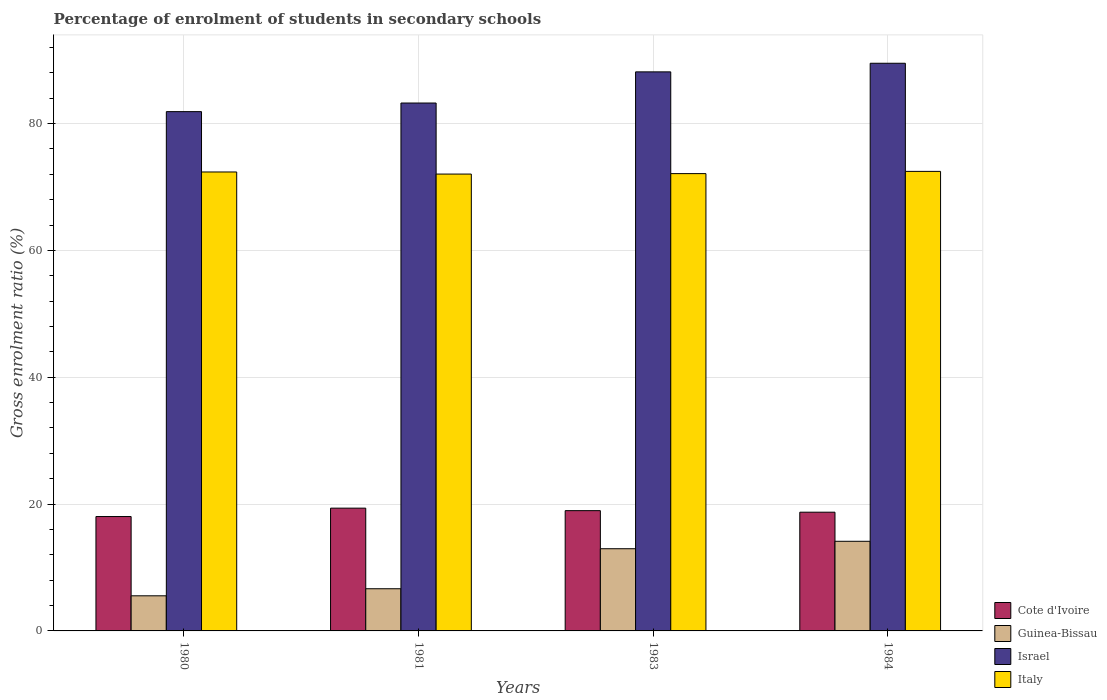How many different coloured bars are there?
Keep it short and to the point. 4. How many groups of bars are there?
Keep it short and to the point. 4. How many bars are there on the 3rd tick from the right?
Give a very brief answer. 4. In how many cases, is the number of bars for a given year not equal to the number of legend labels?
Offer a very short reply. 0. What is the percentage of students enrolled in secondary schools in Cote d'Ivoire in 1983?
Keep it short and to the point. 18.97. Across all years, what is the maximum percentage of students enrolled in secondary schools in Israel?
Offer a very short reply. 89.51. Across all years, what is the minimum percentage of students enrolled in secondary schools in Israel?
Offer a terse response. 81.89. In which year was the percentage of students enrolled in secondary schools in Guinea-Bissau minimum?
Provide a succinct answer. 1980. What is the total percentage of students enrolled in secondary schools in Israel in the graph?
Make the answer very short. 342.8. What is the difference between the percentage of students enrolled in secondary schools in Italy in 1983 and that in 1984?
Your answer should be compact. -0.35. What is the difference between the percentage of students enrolled in secondary schools in Israel in 1980 and the percentage of students enrolled in secondary schools in Italy in 1984?
Give a very brief answer. 9.42. What is the average percentage of students enrolled in secondary schools in Cote d'Ivoire per year?
Offer a terse response. 18.77. In the year 1980, what is the difference between the percentage of students enrolled in secondary schools in Guinea-Bissau and percentage of students enrolled in secondary schools in Israel?
Make the answer very short. -76.35. In how many years, is the percentage of students enrolled in secondary schools in Italy greater than 56 %?
Your response must be concise. 4. What is the ratio of the percentage of students enrolled in secondary schools in Italy in 1980 to that in 1981?
Make the answer very short. 1. Is the percentage of students enrolled in secondary schools in Italy in 1981 less than that in 1983?
Keep it short and to the point. Yes. What is the difference between the highest and the second highest percentage of students enrolled in secondary schools in Cote d'Ivoire?
Make the answer very short. 0.39. What is the difference between the highest and the lowest percentage of students enrolled in secondary schools in Italy?
Your answer should be very brief. 0.43. In how many years, is the percentage of students enrolled in secondary schools in Cote d'Ivoire greater than the average percentage of students enrolled in secondary schools in Cote d'Ivoire taken over all years?
Ensure brevity in your answer.  2. Is the sum of the percentage of students enrolled in secondary schools in Italy in 1980 and 1981 greater than the maximum percentage of students enrolled in secondary schools in Cote d'Ivoire across all years?
Ensure brevity in your answer.  Yes. What does the 2nd bar from the right in 1983 represents?
Your answer should be very brief. Israel. How many bars are there?
Keep it short and to the point. 16. How many years are there in the graph?
Provide a short and direct response. 4. How many legend labels are there?
Keep it short and to the point. 4. How are the legend labels stacked?
Make the answer very short. Vertical. What is the title of the graph?
Your response must be concise. Percentage of enrolment of students in secondary schools. Does "Trinidad and Tobago" appear as one of the legend labels in the graph?
Make the answer very short. No. What is the label or title of the Y-axis?
Give a very brief answer. Gross enrolment ratio (%). What is the Gross enrolment ratio (%) in Cote d'Ivoire in 1980?
Provide a short and direct response. 18.04. What is the Gross enrolment ratio (%) of Guinea-Bissau in 1980?
Your answer should be compact. 5.54. What is the Gross enrolment ratio (%) of Israel in 1980?
Offer a terse response. 81.89. What is the Gross enrolment ratio (%) of Italy in 1980?
Provide a succinct answer. 72.37. What is the Gross enrolment ratio (%) of Cote d'Ivoire in 1981?
Make the answer very short. 19.36. What is the Gross enrolment ratio (%) in Guinea-Bissau in 1981?
Provide a succinct answer. 6.65. What is the Gross enrolment ratio (%) in Israel in 1981?
Your response must be concise. 83.25. What is the Gross enrolment ratio (%) in Italy in 1981?
Offer a terse response. 72.04. What is the Gross enrolment ratio (%) of Cote d'Ivoire in 1983?
Provide a short and direct response. 18.97. What is the Gross enrolment ratio (%) of Guinea-Bissau in 1983?
Provide a succinct answer. 12.96. What is the Gross enrolment ratio (%) of Israel in 1983?
Make the answer very short. 88.16. What is the Gross enrolment ratio (%) in Italy in 1983?
Offer a very short reply. 72.11. What is the Gross enrolment ratio (%) in Cote d'Ivoire in 1984?
Your response must be concise. 18.72. What is the Gross enrolment ratio (%) in Guinea-Bissau in 1984?
Ensure brevity in your answer.  14.13. What is the Gross enrolment ratio (%) in Israel in 1984?
Keep it short and to the point. 89.51. What is the Gross enrolment ratio (%) of Italy in 1984?
Keep it short and to the point. 72.47. Across all years, what is the maximum Gross enrolment ratio (%) in Cote d'Ivoire?
Give a very brief answer. 19.36. Across all years, what is the maximum Gross enrolment ratio (%) in Guinea-Bissau?
Your answer should be compact. 14.13. Across all years, what is the maximum Gross enrolment ratio (%) in Israel?
Provide a succinct answer. 89.51. Across all years, what is the maximum Gross enrolment ratio (%) in Italy?
Give a very brief answer. 72.47. Across all years, what is the minimum Gross enrolment ratio (%) of Cote d'Ivoire?
Give a very brief answer. 18.04. Across all years, what is the minimum Gross enrolment ratio (%) of Guinea-Bissau?
Offer a terse response. 5.54. Across all years, what is the minimum Gross enrolment ratio (%) in Israel?
Give a very brief answer. 81.89. Across all years, what is the minimum Gross enrolment ratio (%) of Italy?
Provide a short and direct response. 72.04. What is the total Gross enrolment ratio (%) in Cote d'Ivoire in the graph?
Give a very brief answer. 75.08. What is the total Gross enrolment ratio (%) in Guinea-Bissau in the graph?
Ensure brevity in your answer.  39.28. What is the total Gross enrolment ratio (%) in Israel in the graph?
Give a very brief answer. 342.8. What is the total Gross enrolment ratio (%) in Italy in the graph?
Offer a very short reply. 288.99. What is the difference between the Gross enrolment ratio (%) of Cote d'Ivoire in 1980 and that in 1981?
Your response must be concise. -1.32. What is the difference between the Gross enrolment ratio (%) of Guinea-Bissau in 1980 and that in 1981?
Keep it short and to the point. -1.11. What is the difference between the Gross enrolment ratio (%) in Israel in 1980 and that in 1981?
Your answer should be compact. -1.36. What is the difference between the Gross enrolment ratio (%) in Italy in 1980 and that in 1981?
Keep it short and to the point. 0.33. What is the difference between the Gross enrolment ratio (%) in Cote d'Ivoire in 1980 and that in 1983?
Your answer should be very brief. -0.93. What is the difference between the Gross enrolment ratio (%) in Guinea-Bissau in 1980 and that in 1983?
Give a very brief answer. -7.42. What is the difference between the Gross enrolment ratio (%) of Israel in 1980 and that in 1983?
Your response must be concise. -6.27. What is the difference between the Gross enrolment ratio (%) in Italy in 1980 and that in 1983?
Give a very brief answer. 0.26. What is the difference between the Gross enrolment ratio (%) in Cote d'Ivoire in 1980 and that in 1984?
Give a very brief answer. -0.68. What is the difference between the Gross enrolment ratio (%) in Guinea-Bissau in 1980 and that in 1984?
Make the answer very short. -8.6. What is the difference between the Gross enrolment ratio (%) in Israel in 1980 and that in 1984?
Your answer should be very brief. -7.63. What is the difference between the Gross enrolment ratio (%) in Italy in 1980 and that in 1984?
Offer a terse response. -0.09. What is the difference between the Gross enrolment ratio (%) of Cote d'Ivoire in 1981 and that in 1983?
Make the answer very short. 0.39. What is the difference between the Gross enrolment ratio (%) in Guinea-Bissau in 1981 and that in 1983?
Make the answer very short. -6.31. What is the difference between the Gross enrolment ratio (%) in Israel in 1981 and that in 1983?
Ensure brevity in your answer.  -4.91. What is the difference between the Gross enrolment ratio (%) in Italy in 1981 and that in 1983?
Offer a terse response. -0.07. What is the difference between the Gross enrolment ratio (%) of Cote d'Ivoire in 1981 and that in 1984?
Make the answer very short. 0.64. What is the difference between the Gross enrolment ratio (%) in Guinea-Bissau in 1981 and that in 1984?
Provide a short and direct response. -7.48. What is the difference between the Gross enrolment ratio (%) in Israel in 1981 and that in 1984?
Your answer should be very brief. -6.27. What is the difference between the Gross enrolment ratio (%) of Italy in 1981 and that in 1984?
Keep it short and to the point. -0.43. What is the difference between the Gross enrolment ratio (%) of Cote d'Ivoire in 1983 and that in 1984?
Offer a terse response. 0.25. What is the difference between the Gross enrolment ratio (%) in Guinea-Bissau in 1983 and that in 1984?
Give a very brief answer. -1.17. What is the difference between the Gross enrolment ratio (%) in Israel in 1983 and that in 1984?
Your answer should be compact. -1.36. What is the difference between the Gross enrolment ratio (%) in Italy in 1983 and that in 1984?
Your answer should be very brief. -0.35. What is the difference between the Gross enrolment ratio (%) of Cote d'Ivoire in 1980 and the Gross enrolment ratio (%) of Guinea-Bissau in 1981?
Your answer should be compact. 11.39. What is the difference between the Gross enrolment ratio (%) of Cote d'Ivoire in 1980 and the Gross enrolment ratio (%) of Israel in 1981?
Your answer should be very brief. -65.21. What is the difference between the Gross enrolment ratio (%) of Cote d'Ivoire in 1980 and the Gross enrolment ratio (%) of Italy in 1981?
Keep it short and to the point. -54. What is the difference between the Gross enrolment ratio (%) in Guinea-Bissau in 1980 and the Gross enrolment ratio (%) in Israel in 1981?
Make the answer very short. -77.71. What is the difference between the Gross enrolment ratio (%) of Guinea-Bissau in 1980 and the Gross enrolment ratio (%) of Italy in 1981?
Your response must be concise. -66.5. What is the difference between the Gross enrolment ratio (%) in Israel in 1980 and the Gross enrolment ratio (%) in Italy in 1981?
Your answer should be very brief. 9.85. What is the difference between the Gross enrolment ratio (%) of Cote d'Ivoire in 1980 and the Gross enrolment ratio (%) of Guinea-Bissau in 1983?
Provide a short and direct response. 5.08. What is the difference between the Gross enrolment ratio (%) in Cote d'Ivoire in 1980 and the Gross enrolment ratio (%) in Israel in 1983?
Ensure brevity in your answer.  -70.12. What is the difference between the Gross enrolment ratio (%) of Cote d'Ivoire in 1980 and the Gross enrolment ratio (%) of Italy in 1983?
Keep it short and to the point. -54.08. What is the difference between the Gross enrolment ratio (%) of Guinea-Bissau in 1980 and the Gross enrolment ratio (%) of Israel in 1983?
Keep it short and to the point. -82.62. What is the difference between the Gross enrolment ratio (%) of Guinea-Bissau in 1980 and the Gross enrolment ratio (%) of Italy in 1983?
Make the answer very short. -66.57. What is the difference between the Gross enrolment ratio (%) in Israel in 1980 and the Gross enrolment ratio (%) in Italy in 1983?
Make the answer very short. 9.77. What is the difference between the Gross enrolment ratio (%) in Cote d'Ivoire in 1980 and the Gross enrolment ratio (%) in Guinea-Bissau in 1984?
Give a very brief answer. 3.9. What is the difference between the Gross enrolment ratio (%) of Cote d'Ivoire in 1980 and the Gross enrolment ratio (%) of Israel in 1984?
Make the answer very short. -71.48. What is the difference between the Gross enrolment ratio (%) in Cote d'Ivoire in 1980 and the Gross enrolment ratio (%) in Italy in 1984?
Your response must be concise. -54.43. What is the difference between the Gross enrolment ratio (%) in Guinea-Bissau in 1980 and the Gross enrolment ratio (%) in Israel in 1984?
Your response must be concise. -83.98. What is the difference between the Gross enrolment ratio (%) of Guinea-Bissau in 1980 and the Gross enrolment ratio (%) of Italy in 1984?
Your answer should be compact. -66.93. What is the difference between the Gross enrolment ratio (%) of Israel in 1980 and the Gross enrolment ratio (%) of Italy in 1984?
Provide a succinct answer. 9.42. What is the difference between the Gross enrolment ratio (%) in Cote d'Ivoire in 1981 and the Gross enrolment ratio (%) in Guinea-Bissau in 1983?
Your answer should be compact. 6.4. What is the difference between the Gross enrolment ratio (%) of Cote d'Ivoire in 1981 and the Gross enrolment ratio (%) of Israel in 1983?
Keep it short and to the point. -68.8. What is the difference between the Gross enrolment ratio (%) in Cote d'Ivoire in 1981 and the Gross enrolment ratio (%) in Italy in 1983?
Provide a short and direct response. -52.75. What is the difference between the Gross enrolment ratio (%) in Guinea-Bissau in 1981 and the Gross enrolment ratio (%) in Israel in 1983?
Make the answer very short. -81.51. What is the difference between the Gross enrolment ratio (%) of Guinea-Bissau in 1981 and the Gross enrolment ratio (%) of Italy in 1983?
Give a very brief answer. -65.46. What is the difference between the Gross enrolment ratio (%) of Israel in 1981 and the Gross enrolment ratio (%) of Italy in 1983?
Offer a very short reply. 11.13. What is the difference between the Gross enrolment ratio (%) of Cote d'Ivoire in 1981 and the Gross enrolment ratio (%) of Guinea-Bissau in 1984?
Provide a succinct answer. 5.23. What is the difference between the Gross enrolment ratio (%) in Cote d'Ivoire in 1981 and the Gross enrolment ratio (%) in Israel in 1984?
Keep it short and to the point. -70.15. What is the difference between the Gross enrolment ratio (%) of Cote d'Ivoire in 1981 and the Gross enrolment ratio (%) of Italy in 1984?
Provide a short and direct response. -53.11. What is the difference between the Gross enrolment ratio (%) of Guinea-Bissau in 1981 and the Gross enrolment ratio (%) of Israel in 1984?
Keep it short and to the point. -82.86. What is the difference between the Gross enrolment ratio (%) in Guinea-Bissau in 1981 and the Gross enrolment ratio (%) in Italy in 1984?
Give a very brief answer. -65.82. What is the difference between the Gross enrolment ratio (%) in Israel in 1981 and the Gross enrolment ratio (%) in Italy in 1984?
Offer a very short reply. 10.78. What is the difference between the Gross enrolment ratio (%) in Cote d'Ivoire in 1983 and the Gross enrolment ratio (%) in Guinea-Bissau in 1984?
Your answer should be compact. 4.83. What is the difference between the Gross enrolment ratio (%) in Cote d'Ivoire in 1983 and the Gross enrolment ratio (%) in Israel in 1984?
Ensure brevity in your answer.  -70.55. What is the difference between the Gross enrolment ratio (%) of Cote d'Ivoire in 1983 and the Gross enrolment ratio (%) of Italy in 1984?
Offer a terse response. -53.5. What is the difference between the Gross enrolment ratio (%) of Guinea-Bissau in 1983 and the Gross enrolment ratio (%) of Israel in 1984?
Ensure brevity in your answer.  -76.55. What is the difference between the Gross enrolment ratio (%) in Guinea-Bissau in 1983 and the Gross enrolment ratio (%) in Italy in 1984?
Keep it short and to the point. -59.5. What is the difference between the Gross enrolment ratio (%) of Israel in 1983 and the Gross enrolment ratio (%) of Italy in 1984?
Offer a terse response. 15.69. What is the average Gross enrolment ratio (%) of Cote d'Ivoire per year?
Give a very brief answer. 18.77. What is the average Gross enrolment ratio (%) in Guinea-Bissau per year?
Your answer should be compact. 9.82. What is the average Gross enrolment ratio (%) of Israel per year?
Keep it short and to the point. 85.7. What is the average Gross enrolment ratio (%) in Italy per year?
Your answer should be very brief. 72.25. In the year 1980, what is the difference between the Gross enrolment ratio (%) in Cote d'Ivoire and Gross enrolment ratio (%) in Guinea-Bissau?
Your answer should be very brief. 12.5. In the year 1980, what is the difference between the Gross enrolment ratio (%) of Cote d'Ivoire and Gross enrolment ratio (%) of Israel?
Offer a very short reply. -63.85. In the year 1980, what is the difference between the Gross enrolment ratio (%) in Cote d'Ivoire and Gross enrolment ratio (%) in Italy?
Ensure brevity in your answer.  -54.33. In the year 1980, what is the difference between the Gross enrolment ratio (%) of Guinea-Bissau and Gross enrolment ratio (%) of Israel?
Give a very brief answer. -76.35. In the year 1980, what is the difference between the Gross enrolment ratio (%) in Guinea-Bissau and Gross enrolment ratio (%) in Italy?
Offer a terse response. -66.83. In the year 1980, what is the difference between the Gross enrolment ratio (%) in Israel and Gross enrolment ratio (%) in Italy?
Your answer should be compact. 9.51. In the year 1981, what is the difference between the Gross enrolment ratio (%) of Cote d'Ivoire and Gross enrolment ratio (%) of Guinea-Bissau?
Offer a terse response. 12.71. In the year 1981, what is the difference between the Gross enrolment ratio (%) of Cote d'Ivoire and Gross enrolment ratio (%) of Israel?
Give a very brief answer. -63.89. In the year 1981, what is the difference between the Gross enrolment ratio (%) in Cote d'Ivoire and Gross enrolment ratio (%) in Italy?
Keep it short and to the point. -52.68. In the year 1981, what is the difference between the Gross enrolment ratio (%) in Guinea-Bissau and Gross enrolment ratio (%) in Israel?
Your response must be concise. -76.6. In the year 1981, what is the difference between the Gross enrolment ratio (%) in Guinea-Bissau and Gross enrolment ratio (%) in Italy?
Your response must be concise. -65.39. In the year 1981, what is the difference between the Gross enrolment ratio (%) in Israel and Gross enrolment ratio (%) in Italy?
Make the answer very short. 11.21. In the year 1983, what is the difference between the Gross enrolment ratio (%) of Cote d'Ivoire and Gross enrolment ratio (%) of Guinea-Bissau?
Give a very brief answer. 6. In the year 1983, what is the difference between the Gross enrolment ratio (%) of Cote d'Ivoire and Gross enrolment ratio (%) of Israel?
Offer a very short reply. -69.19. In the year 1983, what is the difference between the Gross enrolment ratio (%) in Cote d'Ivoire and Gross enrolment ratio (%) in Italy?
Ensure brevity in your answer.  -53.15. In the year 1983, what is the difference between the Gross enrolment ratio (%) in Guinea-Bissau and Gross enrolment ratio (%) in Israel?
Offer a terse response. -75.19. In the year 1983, what is the difference between the Gross enrolment ratio (%) in Guinea-Bissau and Gross enrolment ratio (%) in Italy?
Offer a very short reply. -59.15. In the year 1983, what is the difference between the Gross enrolment ratio (%) of Israel and Gross enrolment ratio (%) of Italy?
Your response must be concise. 16.04. In the year 1984, what is the difference between the Gross enrolment ratio (%) of Cote d'Ivoire and Gross enrolment ratio (%) of Guinea-Bissau?
Offer a terse response. 4.59. In the year 1984, what is the difference between the Gross enrolment ratio (%) of Cote d'Ivoire and Gross enrolment ratio (%) of Israel?
Provide a short and direct response. -70.79. In the year 1984, what is the difference between the Gross enrolment ratio (%) in Cote d'Ivoire and Gross enrolment ratio (%) in Italy?
Ensure brevity in your answer.  -53.74. In the year 1984, what is the difference between the Gross enrolment ratio (%) of Guinea-Bissau and Gross enrolment ratio (%) of Israel?
Offer a very short reply. -75.38. In the year 1984, what is the difference between the Gross enrolment ratio (%) of Guinea-Bissau and Gross enrolment ratio (%) of Italy?
Your answer should be compact. -58.33. In the year 1984, what is the difference between the Gross enrolment ratio (%) in Israel and Gross enrolment ratio (%) in Italy?
Offer a very short reply. 17.05. What is the ratio of the Gross enrolment ratio (%) in Cote d'Ivoire in 1980 to that in 1981?
Your response must be concise. 0.93. What is the ratio of the Gross enrolment ratio (%) of Guinea-Bissau in 1980 to that in 1981?
Your response must be concise. 0.83. What is the ratio of the Gross enrolment ratio (%) in Israel in 1980 to that in 1981?
Offer a terse response. 0.98. What is the ratio of the Gross enrolment ratio (%) in Cote d'Ivoire in 1980 to that in 1983?
Offer a terse response. 0.95. What is the ratio of the Gross enrolment ratio (%) in Guinea-Bissau in 1980 to that in 1983?
Your response must be concise. 0.43. What is the ratio of the Gross enrolment ratio (%) in Israel in 1980 to that in 1983?
Give a very brief answer. 0.93. What is the ratio of the Gross enrolment ratio (%) in Cote d'Ivoire in 1980 to that in 1984?
Provide a succinct answer. 0.96. What is the ratio of the Gross enrolment ratio (%) of Guinea-Bissau in 1980 to that in 1984?
Your response must be concise. 0.39. What is the ratio of the Gross enrolment ratio (%) in Israel in 1980 to that in 1984?
Offer a very short reply. 0.91. What is the ratio of the Gross enrolment ratio (%) of Cote d'Ivoire in 1981 to that in 1983?
Provide a succinct answer. 1.02. What is the ratio of the Gross enrolment ratio (%) of Guinea-Bissau in 1981 to that in 1983?
Offer a terse response. 0.51. What is the ratio of the Gross enrolment ratio (%) in Israel in 1981 to that in 1983?
Make the answer very short. 0.94. What is the ratio of the Gross enrolment ratio (%) of Italy in 1981 to that in 1983?
Ensure brevity in your answer.  1. What is the ratio of the Gross enrolment ratio (%) in Cote d'Ivoire in 1981 to that in 1984?
Offer a terse response. 1.03. What is the ratio of the Gross enrolment ratio (%) in Guinea-Bissau in 1981 to that in 1984?
Your answer should be very brief. 0.47. What is the ratio of the Gross enrolment ratio (%) of Cote d'Ivoire in 1983 to that in 1984?
Your answer should be compact. 1.01. What is the ratio of the Gross enrolment ratio (%) of Guinea-Bissau in 1983 to that in 1984?
Keep it short and to the point. 0.92. What is the ratio of the Gross enrolment ratio (%) in Israel in 1983 to that in 1984?
Keep it short and to the point. 0.98. What is the ratio of the Gross enrolment ratio (%) of Italy in 1983 to that in 1984?
Provide a short and direct response. 1. What is the difference between the highest and the second highest Gross enrolment ratio (%) of Cote d'Ivoire?
Offer a very short reply. 0.39. What is the difference between the highest and the second highest Gross enrolment ratio (%) in Guinea-Bissau?
Offer a terse response. 1.17. What is the difference between the highest and the second highest Gross enrolment ratio (%) of Israel?
Your response must be concise. 1.36. What is the difference between the highest and the second highest Gross enrolment ratio (%) of Italy?
Provide a short and direct response. 0.09. What is the difference between the highest and the lowest Gross enrolment ratio (%) in Cote d'Ivoire?
Keep it short and to the point. 1.32. What is the difference between the highest and the lowest Gross enrolment ratio (%) in Guinea-Bissau?
Give a very brief answer. 8.6. What is the difference between the highest and the lowest Gross enrolment ratio (%) of Israel?
Provide a succinct answer. 7.63. What is the difference between the highest and the lowest Gross enrolment ratio (%) of Italy?
Offer a very short reply. 0.43. 